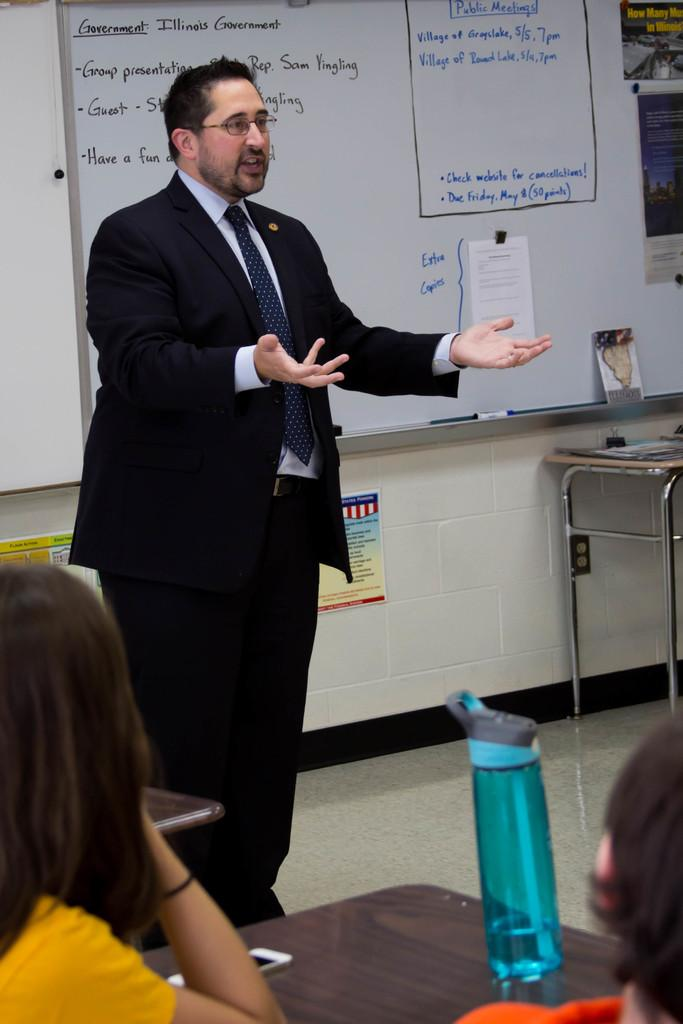<image>
Render a clear and concise summary of the photo. A white board has a section labeled public meetings. 